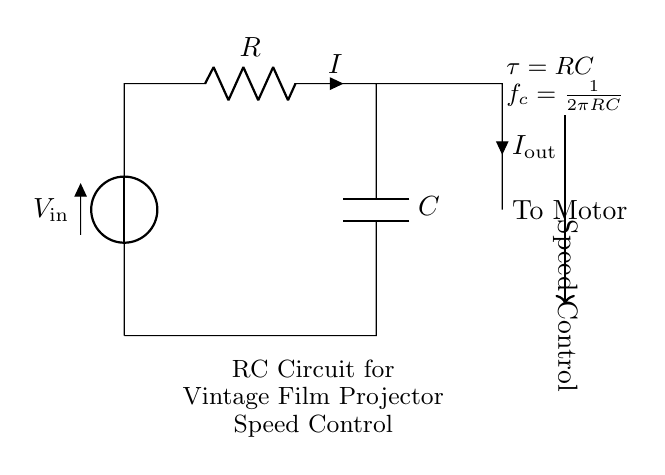What type of circuit is shown? This circuit is an RC circuit, which consists of a resistor and a capacitor connected in series. It's often used for timing applications or filters.
Answer: RC circuit What component controls the current? The resistor acts as a current limiter, controlling the amount of current that flows through the circuit.
Answer: Resistor What is the role of the capacitor? The capacitor stores electrical energy and releases it over time, allowing the circuit to control the speed of the motor by adjusting the charge and discharge rate.
Answer: Speed control What does "tau" represent in the circuit? "Tau" represents the time constant of the circuit, calculated as the product of resistance and capacitance, which determines how quickly the circuit responds to changes.
Answer: RC What is the formula for the cutoff frequency? The cutoff frequency formula is derived from the values of resistance and capacitance, specifically as the reciprocal of 2 pi times the product of these two values.
Answer: 1 over 2 pi RC How does increasing resistance affect the speed of the motor? Increasing resistance lowers the current and can slow the charging rate of the capacitor, resulting in a slower motor speed.
Answer: Slower What is "I out" in the context of this circuit? "I out" refers to the output current that will flow to the motor, indicating how much current is being delivered to power it based on the input voltage and resistance of the circuit.
Answer: Output current 